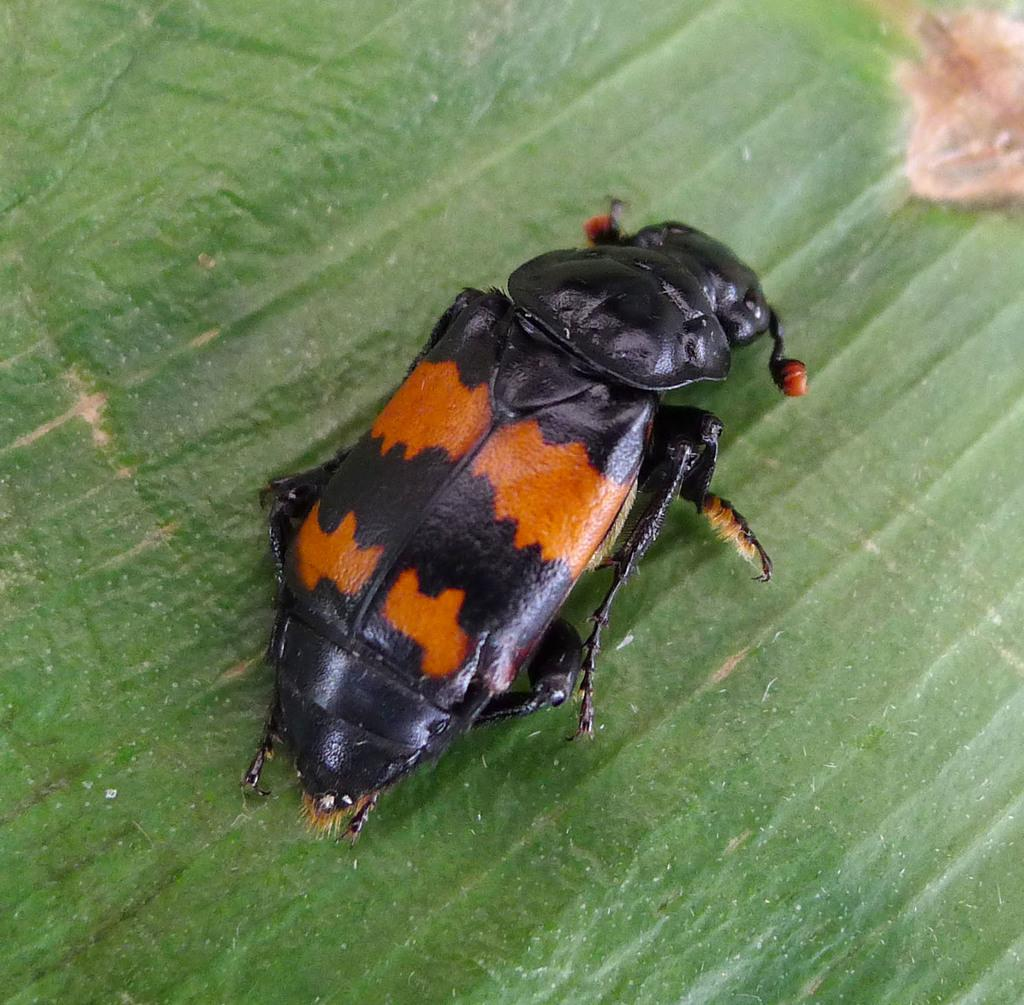What is the main subject in the middle of the image? There is an insect in the middle of the image. What can be seen at the bottom of the image? There is a leaf at the bottom of the image. What type of cellar can be seen in the image? There is no cellar present in the image. 